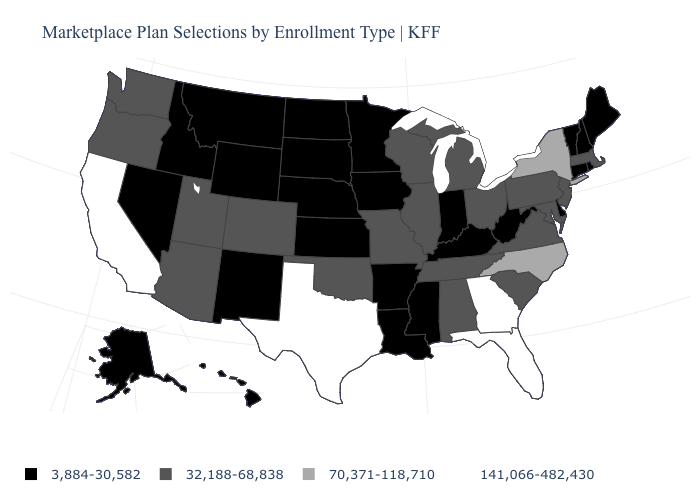What is the value of Montana?
Answer briefly. 3,884-30,582. What is the value of Nebraska?
Give a very brief answer. 3,884-30,582. Does the first symbol in the legend represent the smallest category?
Quick response, please. Yes. Among the states that border Rhode Island , which have the highest value?
Answer briefly. Massachusetts. Name the states that have a value in the range 32,188-68,838?
Keep it brief. Alabama, Arizona, Colorado, Illinois, Maryland, Massachusetts, Michigan, Missouri, New Jersey, Ohio, Oklahoma, Oregon, Pennsylvania, South Carolina, Tennessee, Utah, Virginia, Washington, Wisconsin. Name the states that have a value in the range 70,371-118,710?
Short answer required. New York, North Carolina. Name the states that have a value in the range 3,884-30,582?
Short answer required. Alaska, Arkansas, Connecticut, Delaware, Hawaii, Idaho, Indiana, Iowa, Kansas, Kentucky, Louisiana, Maine, Minnesota, Mississippi, Montana, Nebraska, Nevada, New Hampshire, New Mexico, North Dakota, Rhode Island, South Dakota, Vermont, West Virginia, Wyoming. Does California have the highest value in the USA?
Quick response, please. Yes. What is the value of Indiana?
Short answer required. 3,884-30,582. Does Nevada have the lowest value in the West?
Give a very brief answer. Yes. Does Utah have the lowest value in the West?
Concise answer only. No. Does Nebraska have a lower value than Florida?
Short answer required. Yes. What is the lowest value in states that border Oregon?
Write a very short answer. 3,884-30,582. What is the value of Kentucky?
Give a very brief answer. 3,884-30,582. 